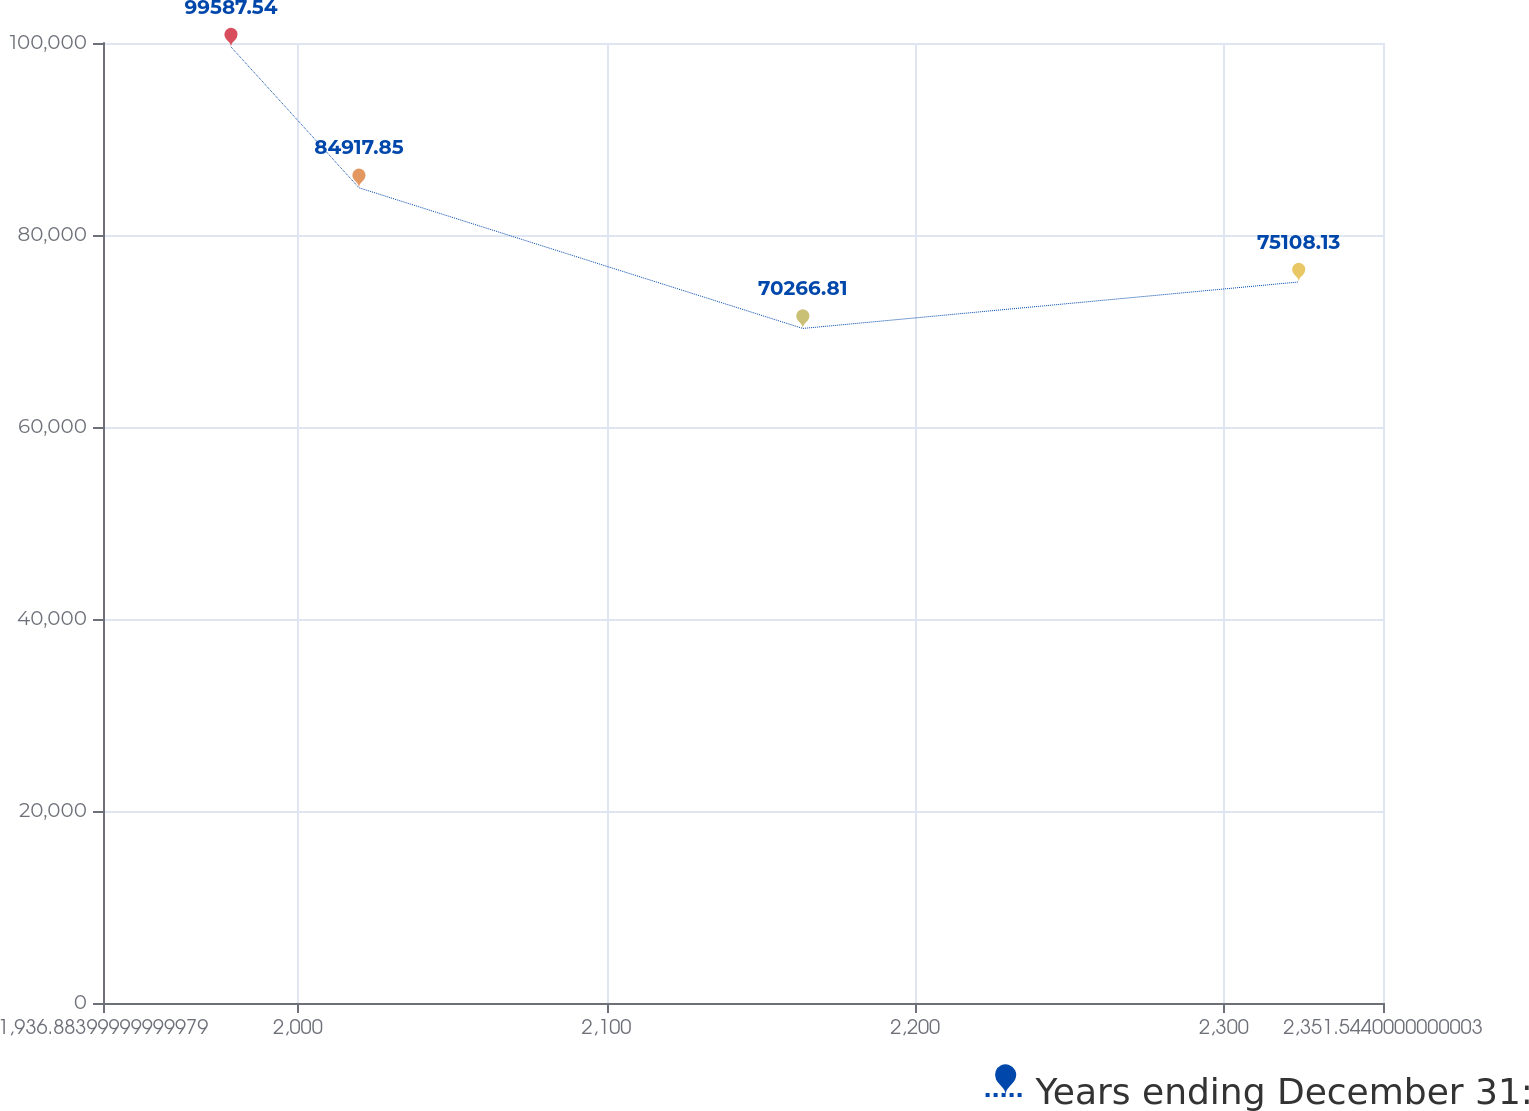Convert chart. <chart><loc_0><loc_0><loc_500><loc_500><line_chart><ecel><fcel>Years ending December 31:<nl><fcel>1978.35<fcel>99587.5<nl><fcel>2019.82<fcel>84917.9<nl><fcel>2163.59<fcel>70266.8<nl><fcel>2324.25<fcel>75108.1<nl><fcel>2393.01<fcel>51174.3<nl></chart> 